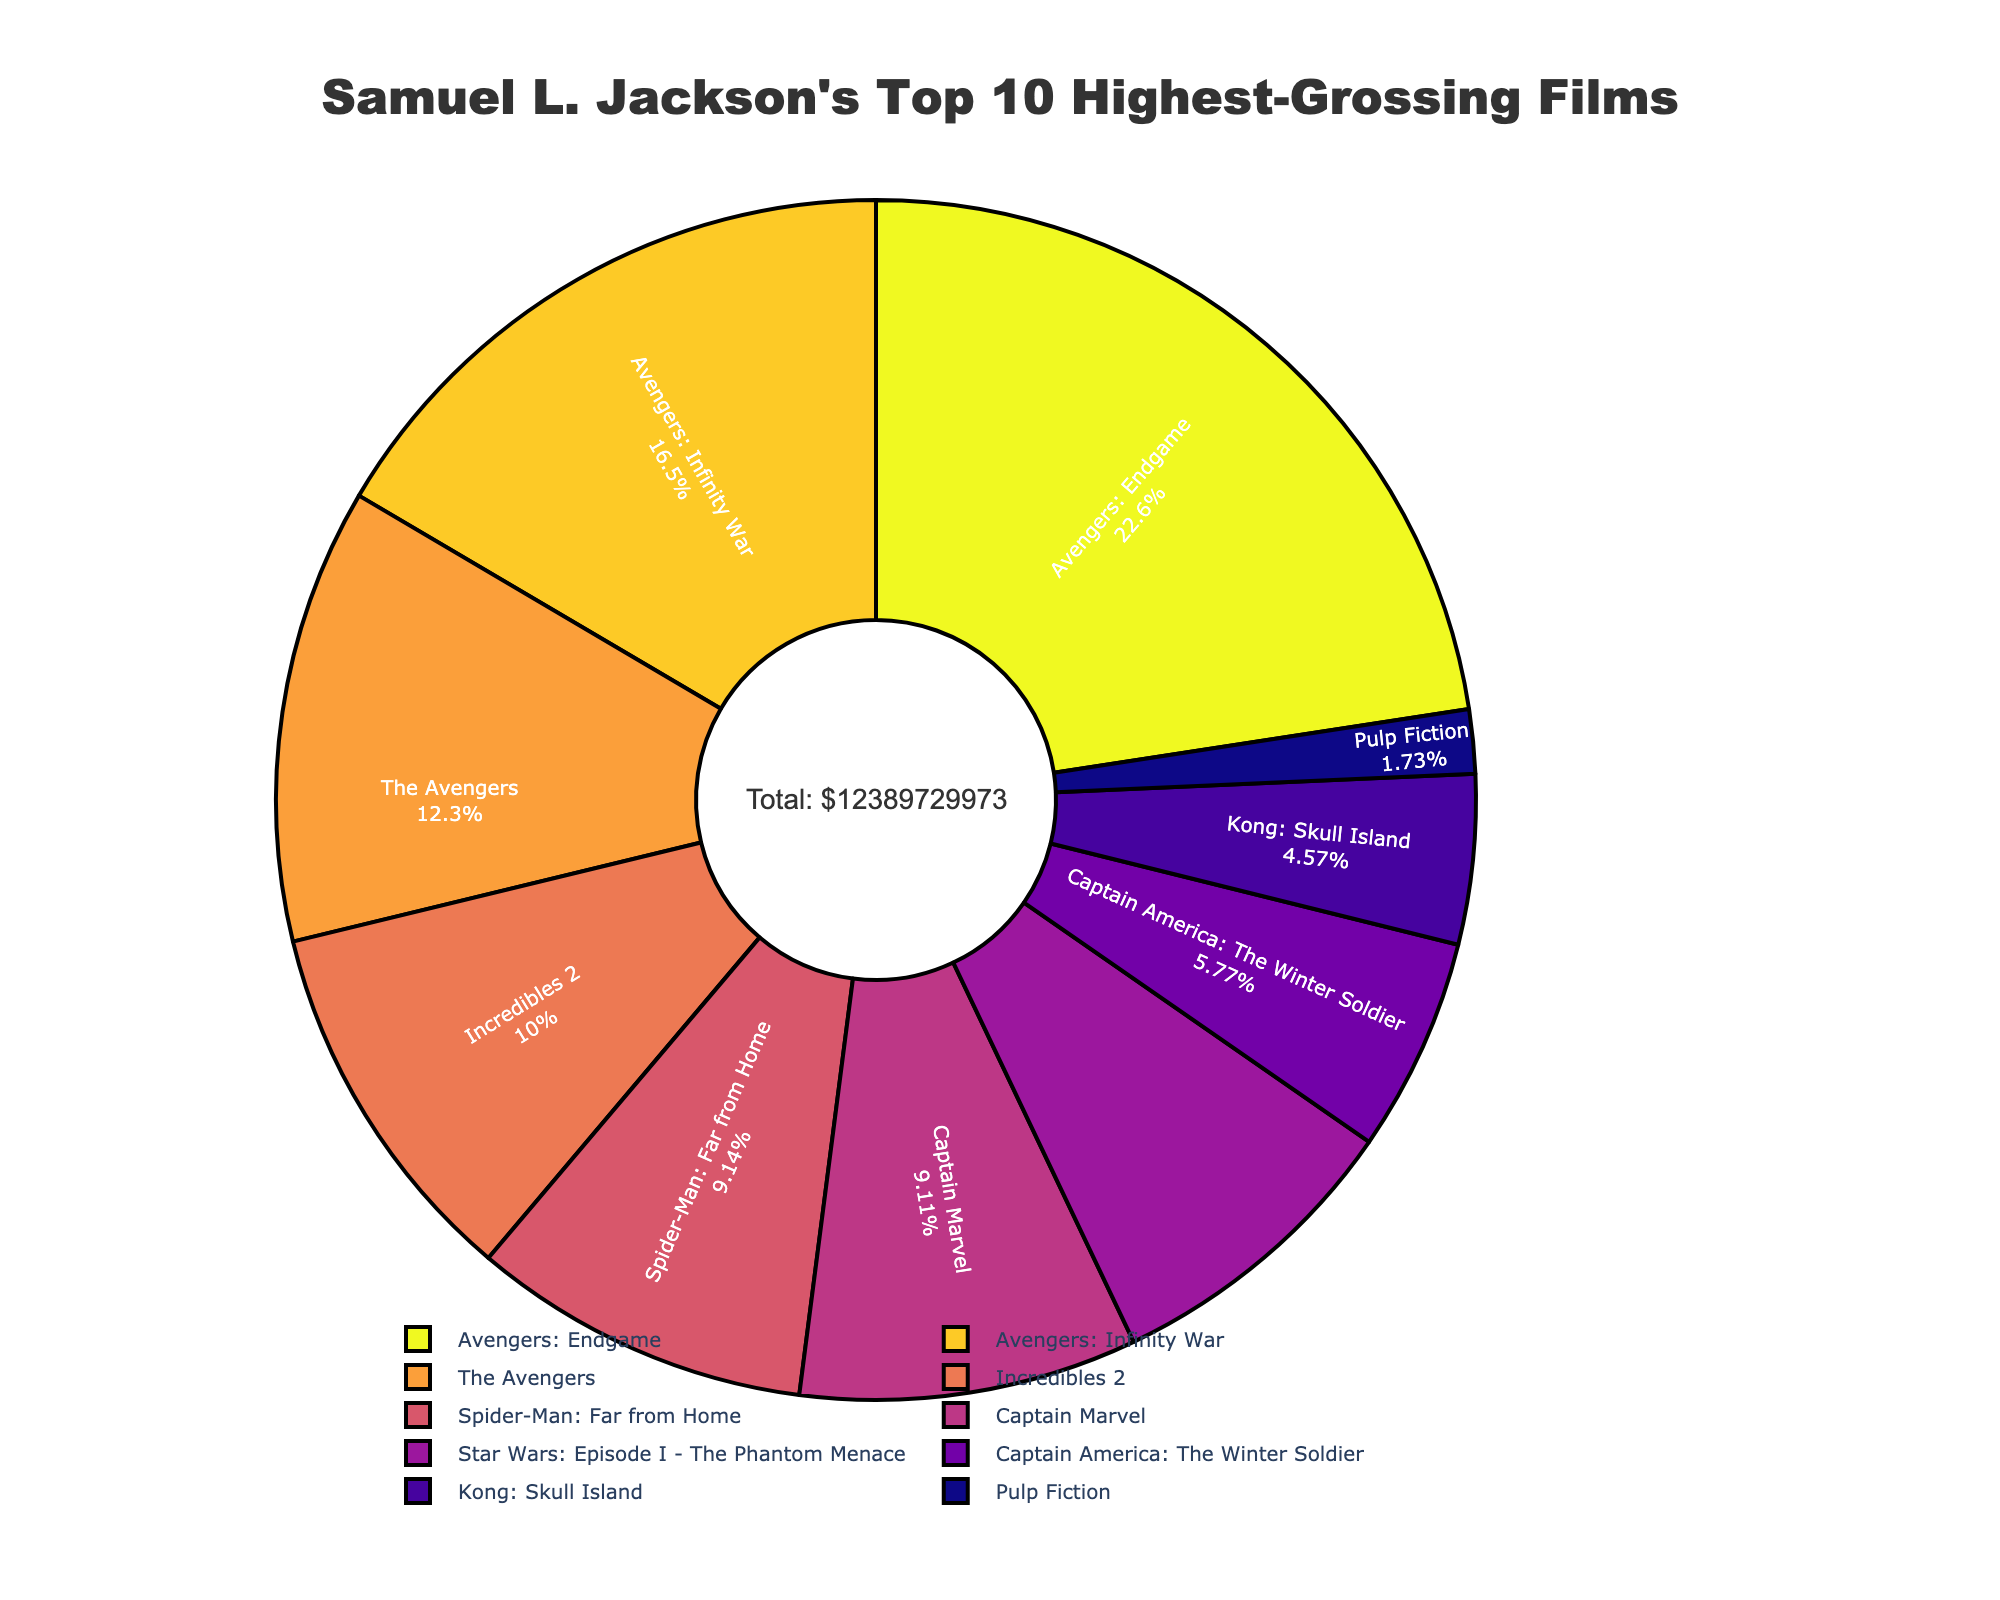Which movie has the highest box office revenue? The pie chart shows "Avengers: Endgame" occupying the largest segment of the chart, indicating it has the highest box office revenue among the listed movies.
Answer: Avengers: Endgame Which movie has the smallest box office revenue? The smallest segment in the pie chart is labeled "Pulp Fiction," indicating it has the smallest box office revenue compared to the other movies.
Answer: Pulp Fiction What percentage of the total box office revenue is generated by "Avengers: Endgame"? The pie chart provides the percentage for each movie; by looking at the "Avengers: Endgame" segment, it shows 24.0%.
Answer: 24.0% How does the box office revenue of "Captain Marvel" compare to "Spider-Man: Far from Home"? The pie chart shows the segments for "Captain Marvel" and "Spider-Man: Far from Home" and their percentages. Both are nearly equal in size and the percentages are almost the same: "Captain Marvel" is 10.4% and "Spider-Man: Far from Home" is 10.4%.
Answer: They are nearly equal What is the combined box office revenue percentage of "The Avengers" and "Incredibles 2"? To find the combined percentage, add the individual percentages for "The Avengers" (13.2%) and "Incredibles 2" (10.8%) from the pie chart. The combined percentage is 13.2% + 10.8% = 24.0%.
Answer: 24.0% Is the box office revenue of "Star Wars: Episode I - The Phantom Menace" greater than "Captain America: The Winter Soldier"? Compare the sizes and percentages provided in the pie chart. "Star Wars: Episode I - The Phantom Menace" is 8.9% which is larger than "Captain America: The Winter Soldier" which is 6.2%.
Answer: Yes What percentage of the total box office revenue is composed of the bottom three movies? Identify the bottom three movies "Kong: Skull Island" (4.9%), "Captain America: The Winter Soldier" (6.2%), and "Pulp Fiction" (1.9%). Calculate the combined percentage as 4.9% + 6.2% + 1.9% = 13.0%.
Answer: 13.0% Which movies combined contribute more than 20% but less than 30% of the total revenue? By examining the pie chart, "The Avengers" (13.2%) and "Incredibles 2" (10.8%) together sum up to 24.0%. These movies fit into the specified range.
Answer: The Avengers and Incredibles 2 What is the total box office revenue for the listed movies? The pie chart includes an annotation indicating the total box office revenue for all the listed movies, which is $12,283,834,973.
Answer: $12,283,834,973 